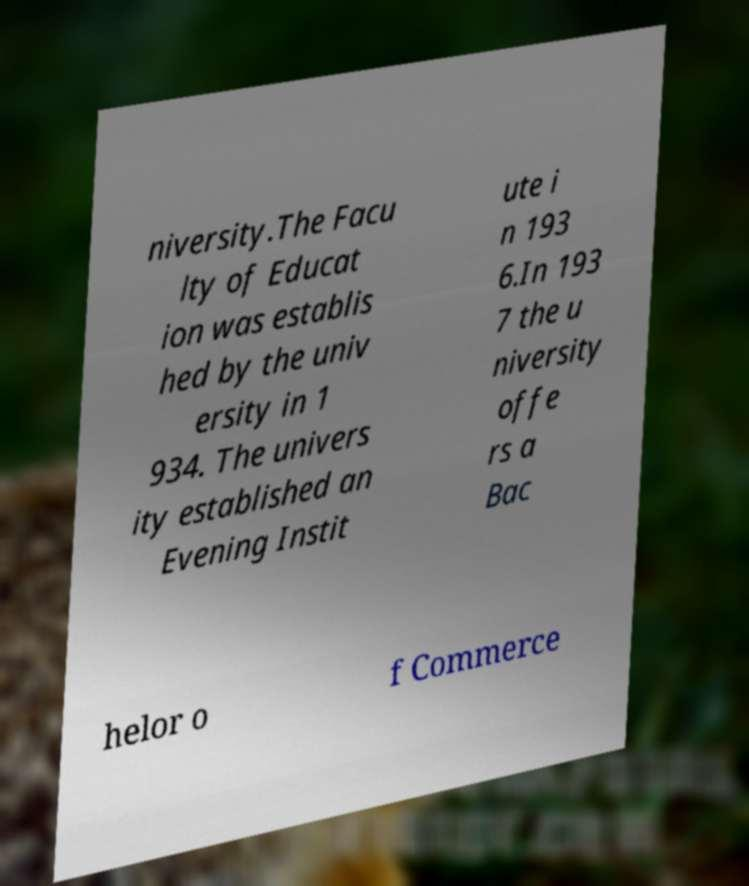Can you accurately transcribe the text from the provided image for me? niversity.The Facu lty of Educat ion was establis hed by the univ ersity in 1 934. The univers ity established an Evening Instit ute i n 193 6.In 193 7 the u niversity offe rs a Bac helor o f Commerce 